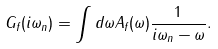Convert formula to latex. <formula><loc_0><loc_0><loc_500><loc_500>G _ { f } ( i \omega _ { n } ) = \int d \omega A _ { f } ( \omega ) \frac { 1 } { i \omega _ { n } - \omega } .</formula> 